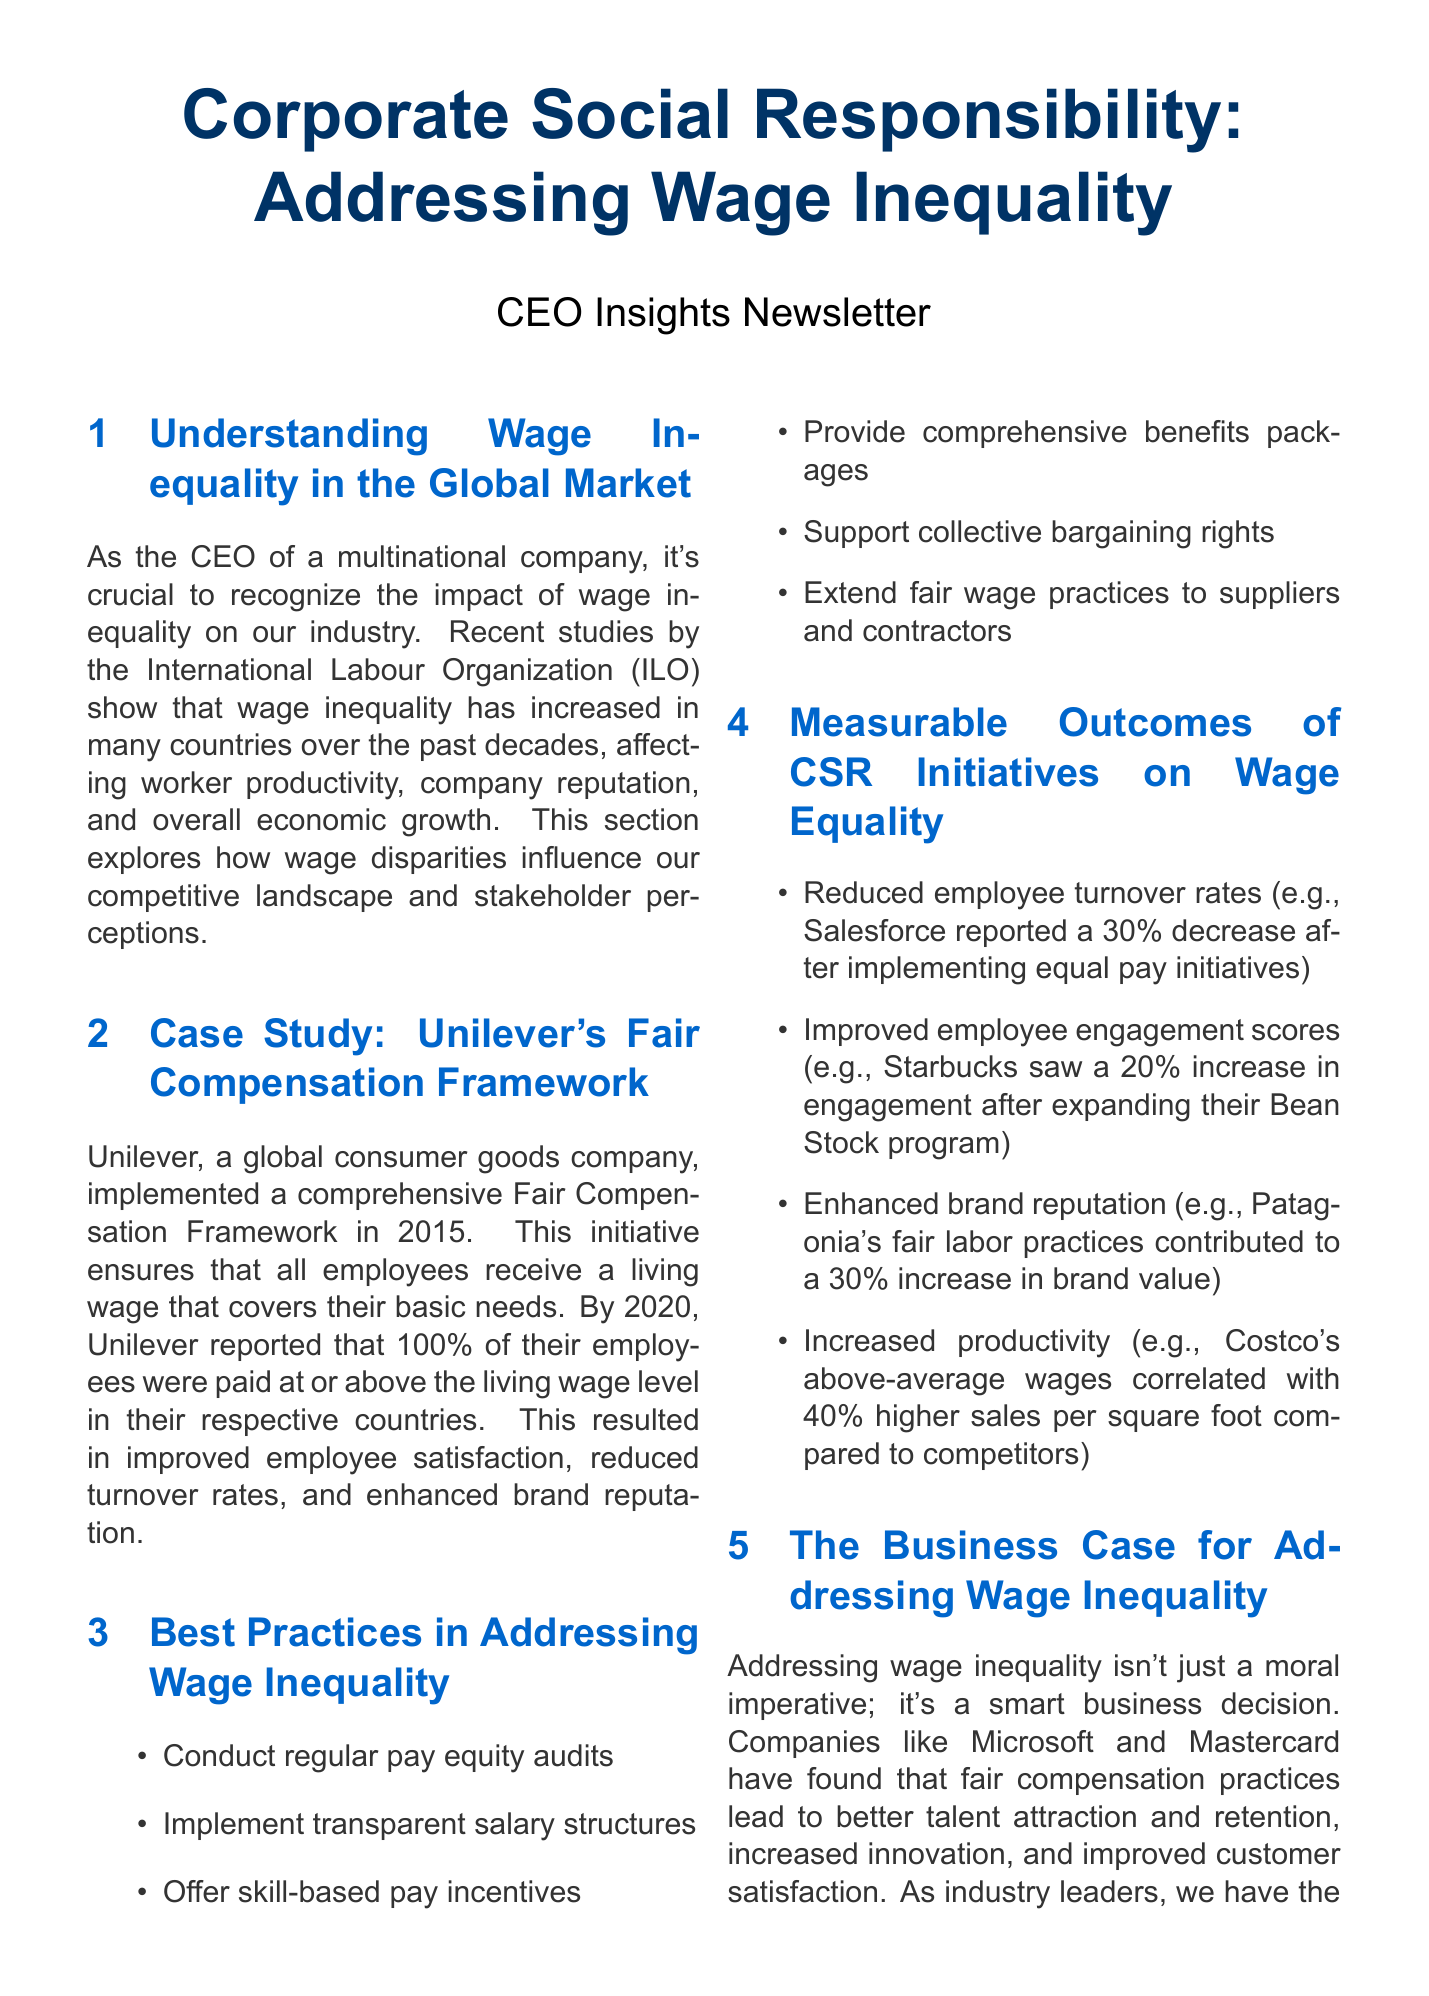What is the title of the newsletter? The title of the newsletter is prominently displayed at the beginning of the document.
Answer: Corporate Social Responsibility: Addressing Wage Inequality Who implemented a Fair Compensation Framework in 2015? This information is found in the case study section discussing a global consumer goods company's initiative.
Answer: Unilever What percentage of Unilever's employees were paid at or above the living wage level by 2020? This percentage is reported as part of the outcomes of the Fair Compensation Framework.
Answer: 100% What was the decrease in employee turnover rates reported by Salesforce? This figure is highlighted in the section discussing measurable outcomes of CSR initiatives on wage equality.
Answer: 30% Name one global initiative or organization mentioned for partnerships. This is found in the section that discusses collaboration opportunities in addressing wage inequality.
Answer: United Nations Global Compact What technology can help identify and address wage gaps? The document discusses specific technologies that aid in promoting pay equity.
Answer: AI and data analytics What impact did Patagonia's fair labor practices have on brand value? This effect is mentioned in the measurable outcomes section, illustrating the benefits of fair practices.
Answer: 30% increase What is one of the best practices listed for addressing wage inequality? This is found in a section where the newsletter outlines effective strategies for companies.
Answer: Conduct regular pay equity audits How much higher were Costco's sales per square foot compared to competitors due to above-average wages? This statistic is presented as an example of increased productivity related to wage practices.
Answer: 40% 